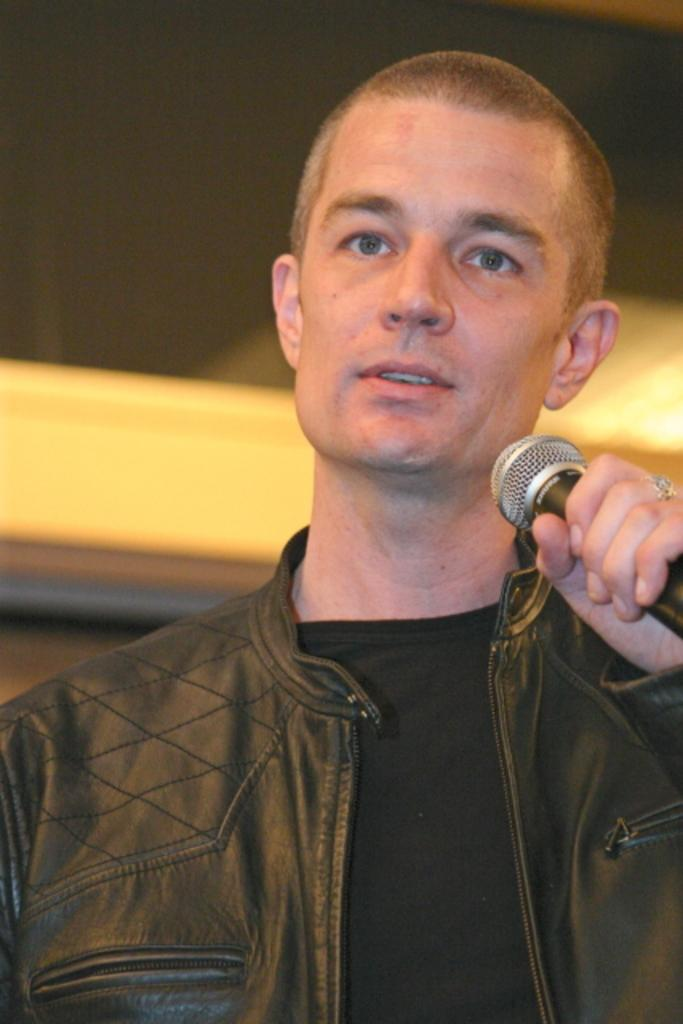Who is the main subject in the image? There is a man in the image. What is the man holding in the image? The man is holding a microphone. What type of clothing is the man wearing? The man is wearing a jacket. Can you describe the background of the image? The background of the image is blurry. What type of vase can be seen in the background of the image? There is no vase present in the image; the background is blurry. 